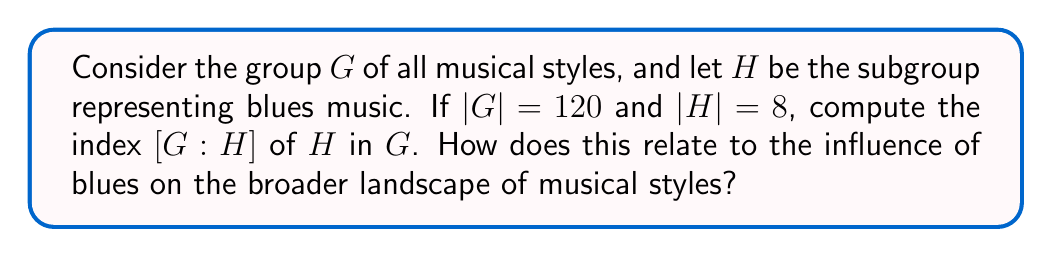What is the answer to this math problem? To solve this problem, we need to understand the concept of index in group theory and how it relates to our musical context:

1) In group theory, the index of a subgroup $H$ in a group $G$, denoted as $[G:H]$, is defined as the number of distinct left (or right) cosets of $H$ in $G$.

2) For finite groups, there's a fundamental theorem that relates the order of the group, the order of the subgroup, and the index:

   $$[G:H] = \frac{|G|}{|H|}$$

   Where $|G|$ is the order (number of elements) of group $G$, and $|H|$ is the order of subgroup $H$.

3) In our case:
   $|G| = 120$ (total number of musical styles)
   $|H| = 8$ (number of blues styles)

4) Applying the formula:

   $$[G:H] = \frac{|G|}{|H|} = \frac{120}{8} = 15$$

5) Interpretation in the context of music history:
   The index of 15 suggests that blues (represented by subgroup $H$) forms one of 15 distinct categories within the larger group of all musical styles. This mathematical relationship could be seen as a quantitative representation of how blues fits into and influences the broader musical landscape. Each of these 15 categories (cosets) could be thought of as a family of musical styles that are related to blues in some fundamental way, highlighting the far-reaching impact of blues on various genres of music.
Answer: The index $[G:H] = 15$ 